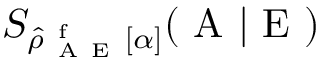Convert formula to latex. <formula><loc_0><loc_0><loc_500><loc_500>S _ { \hat { \rho } _ { A E } ^ { f } [ \alpha ] } ( A | E )</formula> 